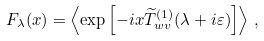<formula> <loc_0><loc_0><loc_500><loc_500>F _ { \lambda } ( x ) = \left \langle \exp \left [ - i x \widetilde { T } _ { w v } ^ { ( 1 ) } ( \lambda + i \varepsilon ) \right ] \right \rangle \, ,</formula> 